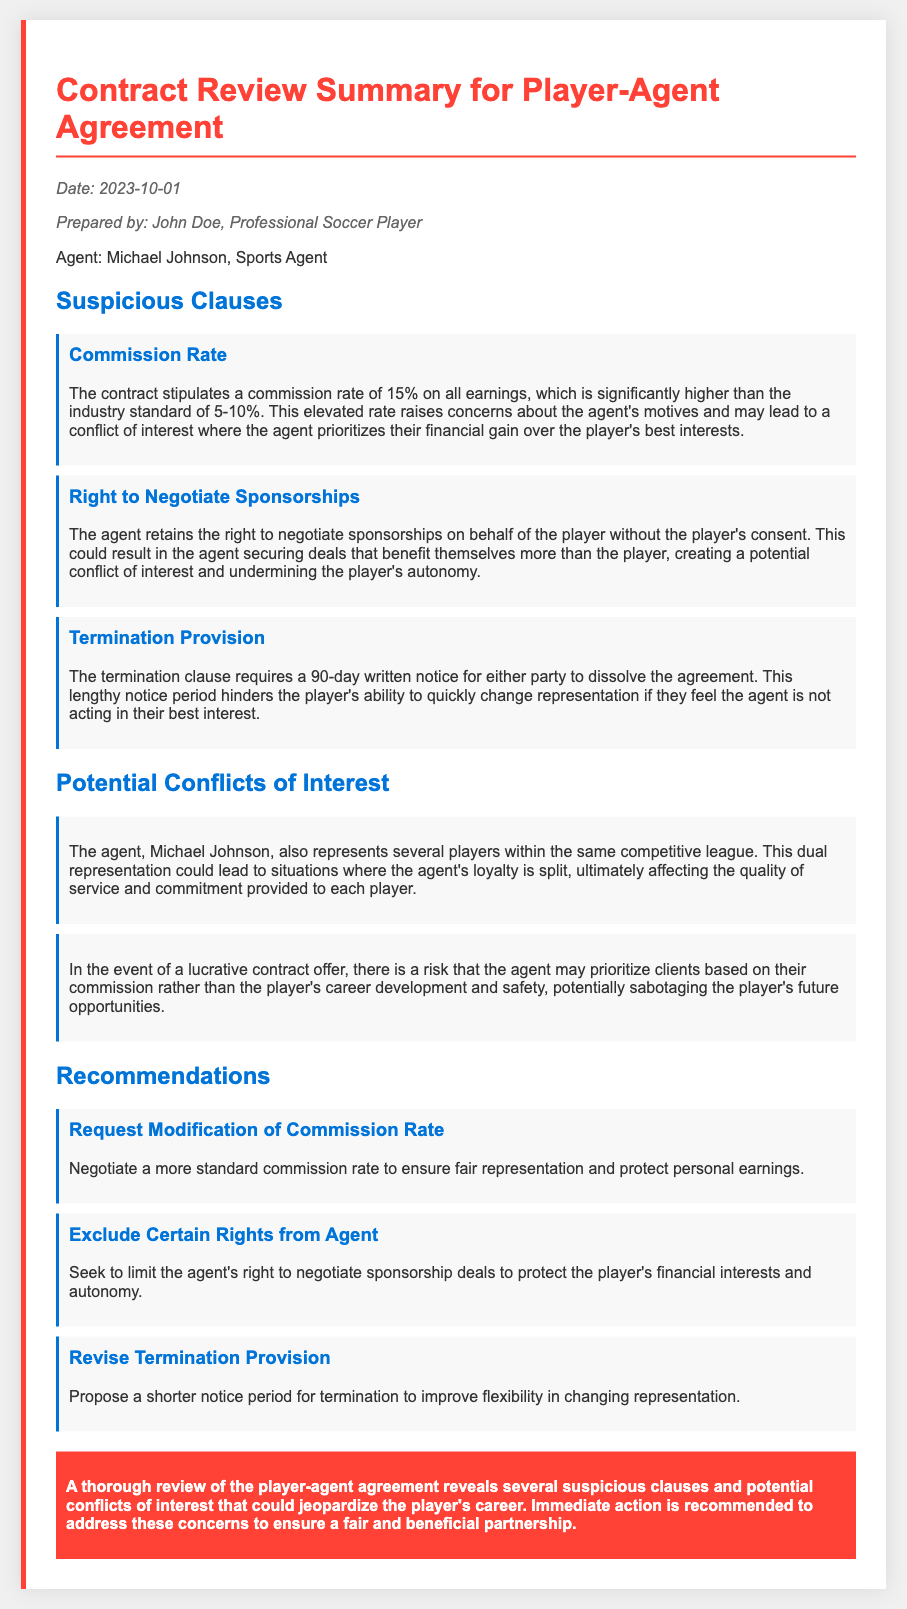What is the commission rate stated in the contract? The contract specifies a commission rate of 15% on all earnings, which is highlighted as suspicious.
Answer: 15% Who is the agent listed in the agreement? The document names Michael Johnson as the sports agent for the player.
Answer: Michael Johnson What is the required notice period for termination of the agreement? The termination clause necessitates a 90-day written notice for either party to dissolve the agreement.
Answer: 90 days What is a potential conflict of interest mentioned in the memo? One potential conflict is that the agent represents several players within the same competitive league.
Answer: Dual representation What recommendation is made regarding the commission rate? The memo recommends negotiating a more standard commission rate to ensure fair representation.
Answer: Standard commission rate What is one of the suspicious clauses concerning sponsorships? The agent retains the right to negotiate sponsorships on behalf of the player without consent.
Answer: Right to negotiate sponsorships What date was the memo prepared? The memo was prepared on October 1, 2023, as indicated in the document.
Answer: October 1, 2023 What does the conclusion recommend? The conclusion emphasizes immediate action to address suspicious clauses and conflicts to protect the player's career.
Answer: Immediate action 